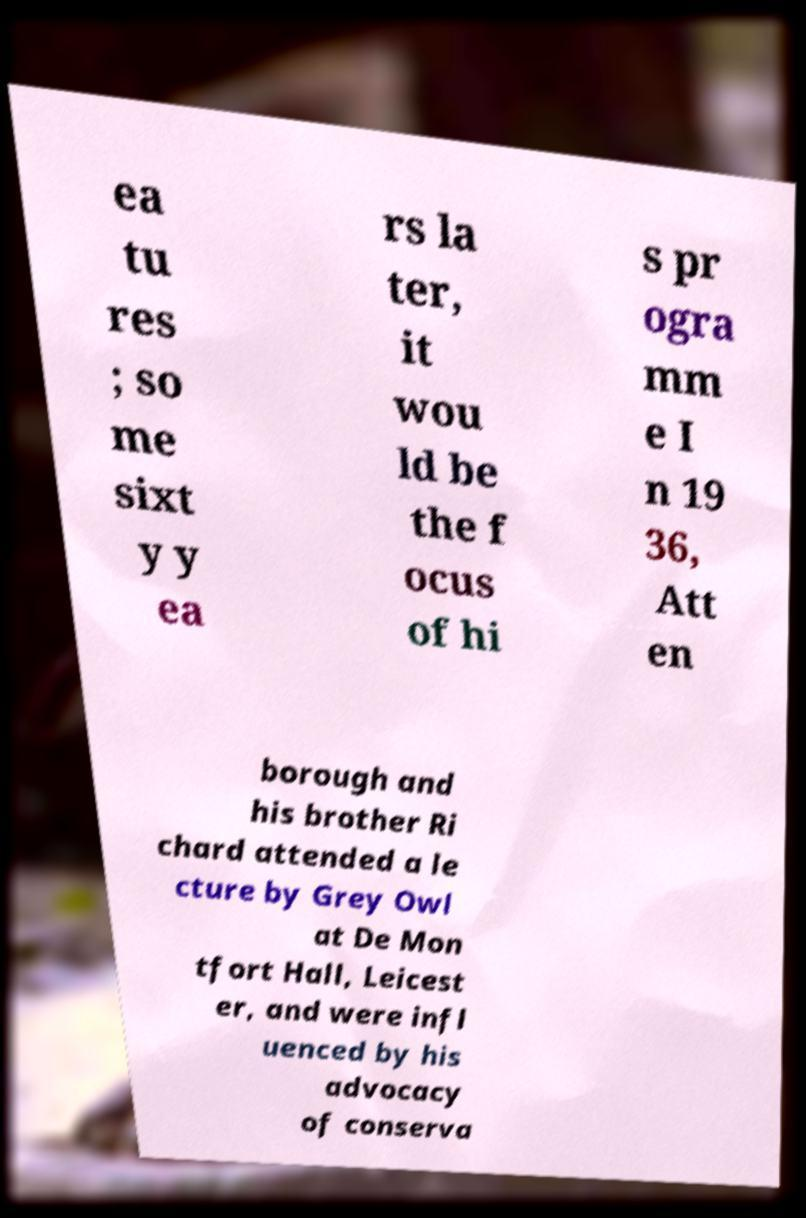Please read and relay the text visible in this image. What does it say? ea tu res ; so me sixt y y ea rs la ter, it wou ld be the f ocus of hi s pr ogra mm e I n 19 36, Att en borough and his brother Ri chard attended a le cture by Grey Owl at De Mon tfort Hall, Leicest er, and were infl uenced by his advocacy of conserva 